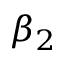<formula> <loc_0><loc_0><loc_500><loc_500>\beta _ { 2 }</formula> 